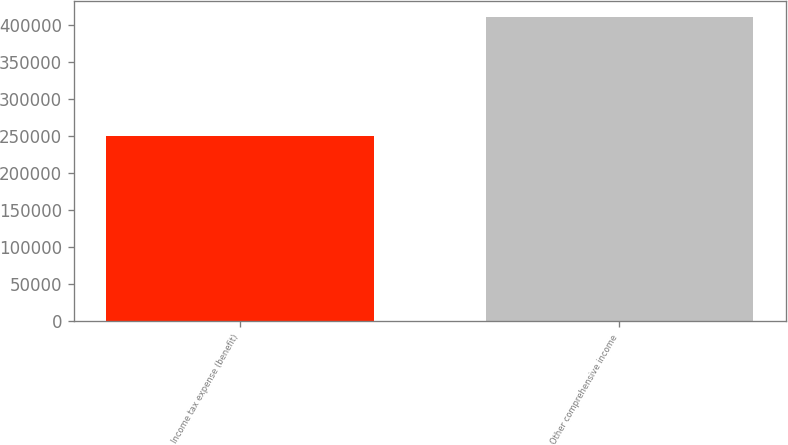Convert chart to OTSL. <chart><loc_0><loc_0><loc_500><loc_500><bar_chart><fcel>Income tax expense (benefit)<fcel>Other comprehensive income<nl><fcel>249894<fcel>411646<nl></chart> 